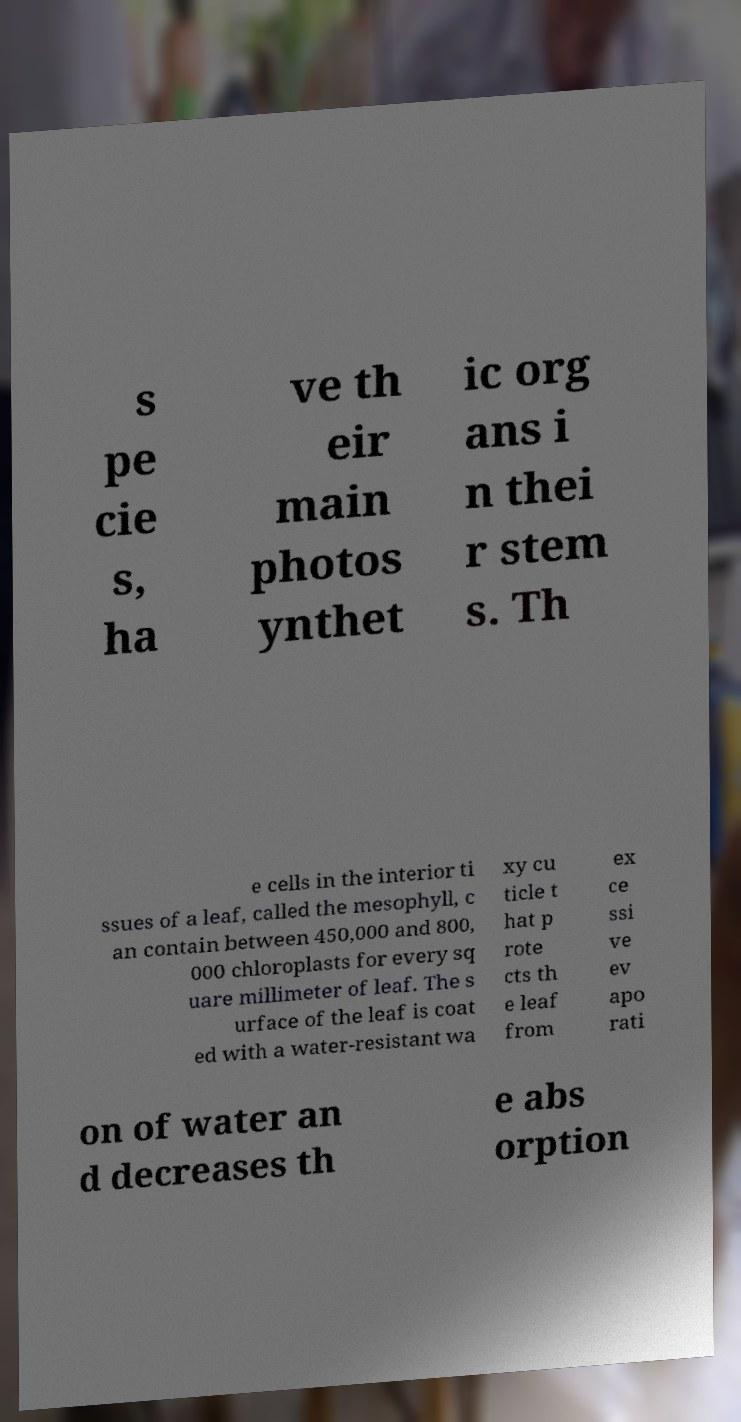There's text embedded in this image that I need extracted. Can you transcribe it verbatim? s pe cie s, ha ve th eir main photos ynthet ic org ans i n thei r stem s. Th e cells in the interior ti ssues of a leaf, called the mesophyll, c an contain between 450,000 and 800, 000 chloroplasts for every sq uare millimeter of leaf. The s urface of the leaf is coat ed with a water-resistant wa xy cu ticle t hat p rote cts th e leaf from ex ce ssi ve ev apo rati on of water an d decreases th e abs orption 